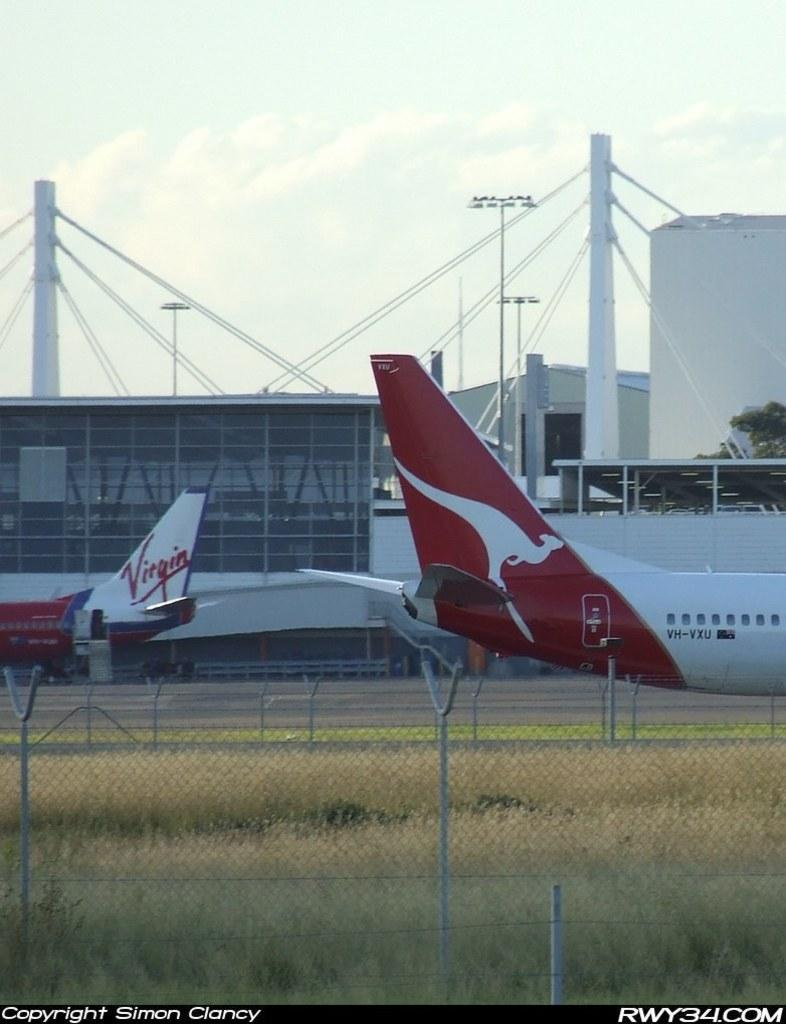<image>
Relay a brief, clear account of the picture shown. An airplane from Virgin airlines and an airplane with a kangaroo on it's tail 